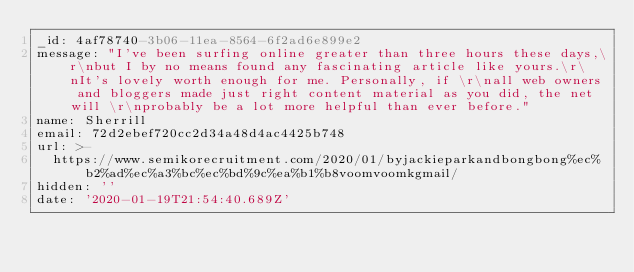Convert code to text. <code><loc_0><loc_0><loc_500><loc_500><_YAML_>_id: 4af78740-3b06-11ea-8564-6f2ad6e899e2
message: "I've been surfing online greater than three hours these days,\r\nbut I by no means found any fascinating article like yours.\r\nIt's lovely worth enough for me. Personally, if \r\nall web owners and bloggers made just right content material as you did, the net will \r\nprobably be a lot more helpful than ever before."
name: Sherrill
email: 72d2ebef720cc2d34a48d4ac4425b748
url: >-
  https://www.semikorecruitment.com/2020/01/byjackieparkandbongbong%ec%b2%ad%ec%a3%bc%ec%bd%9c%ea%b1%b8voomvoomkgmail/
hidden: ''
date: '2020-01-19T21:54:40.689Z'
</code> 